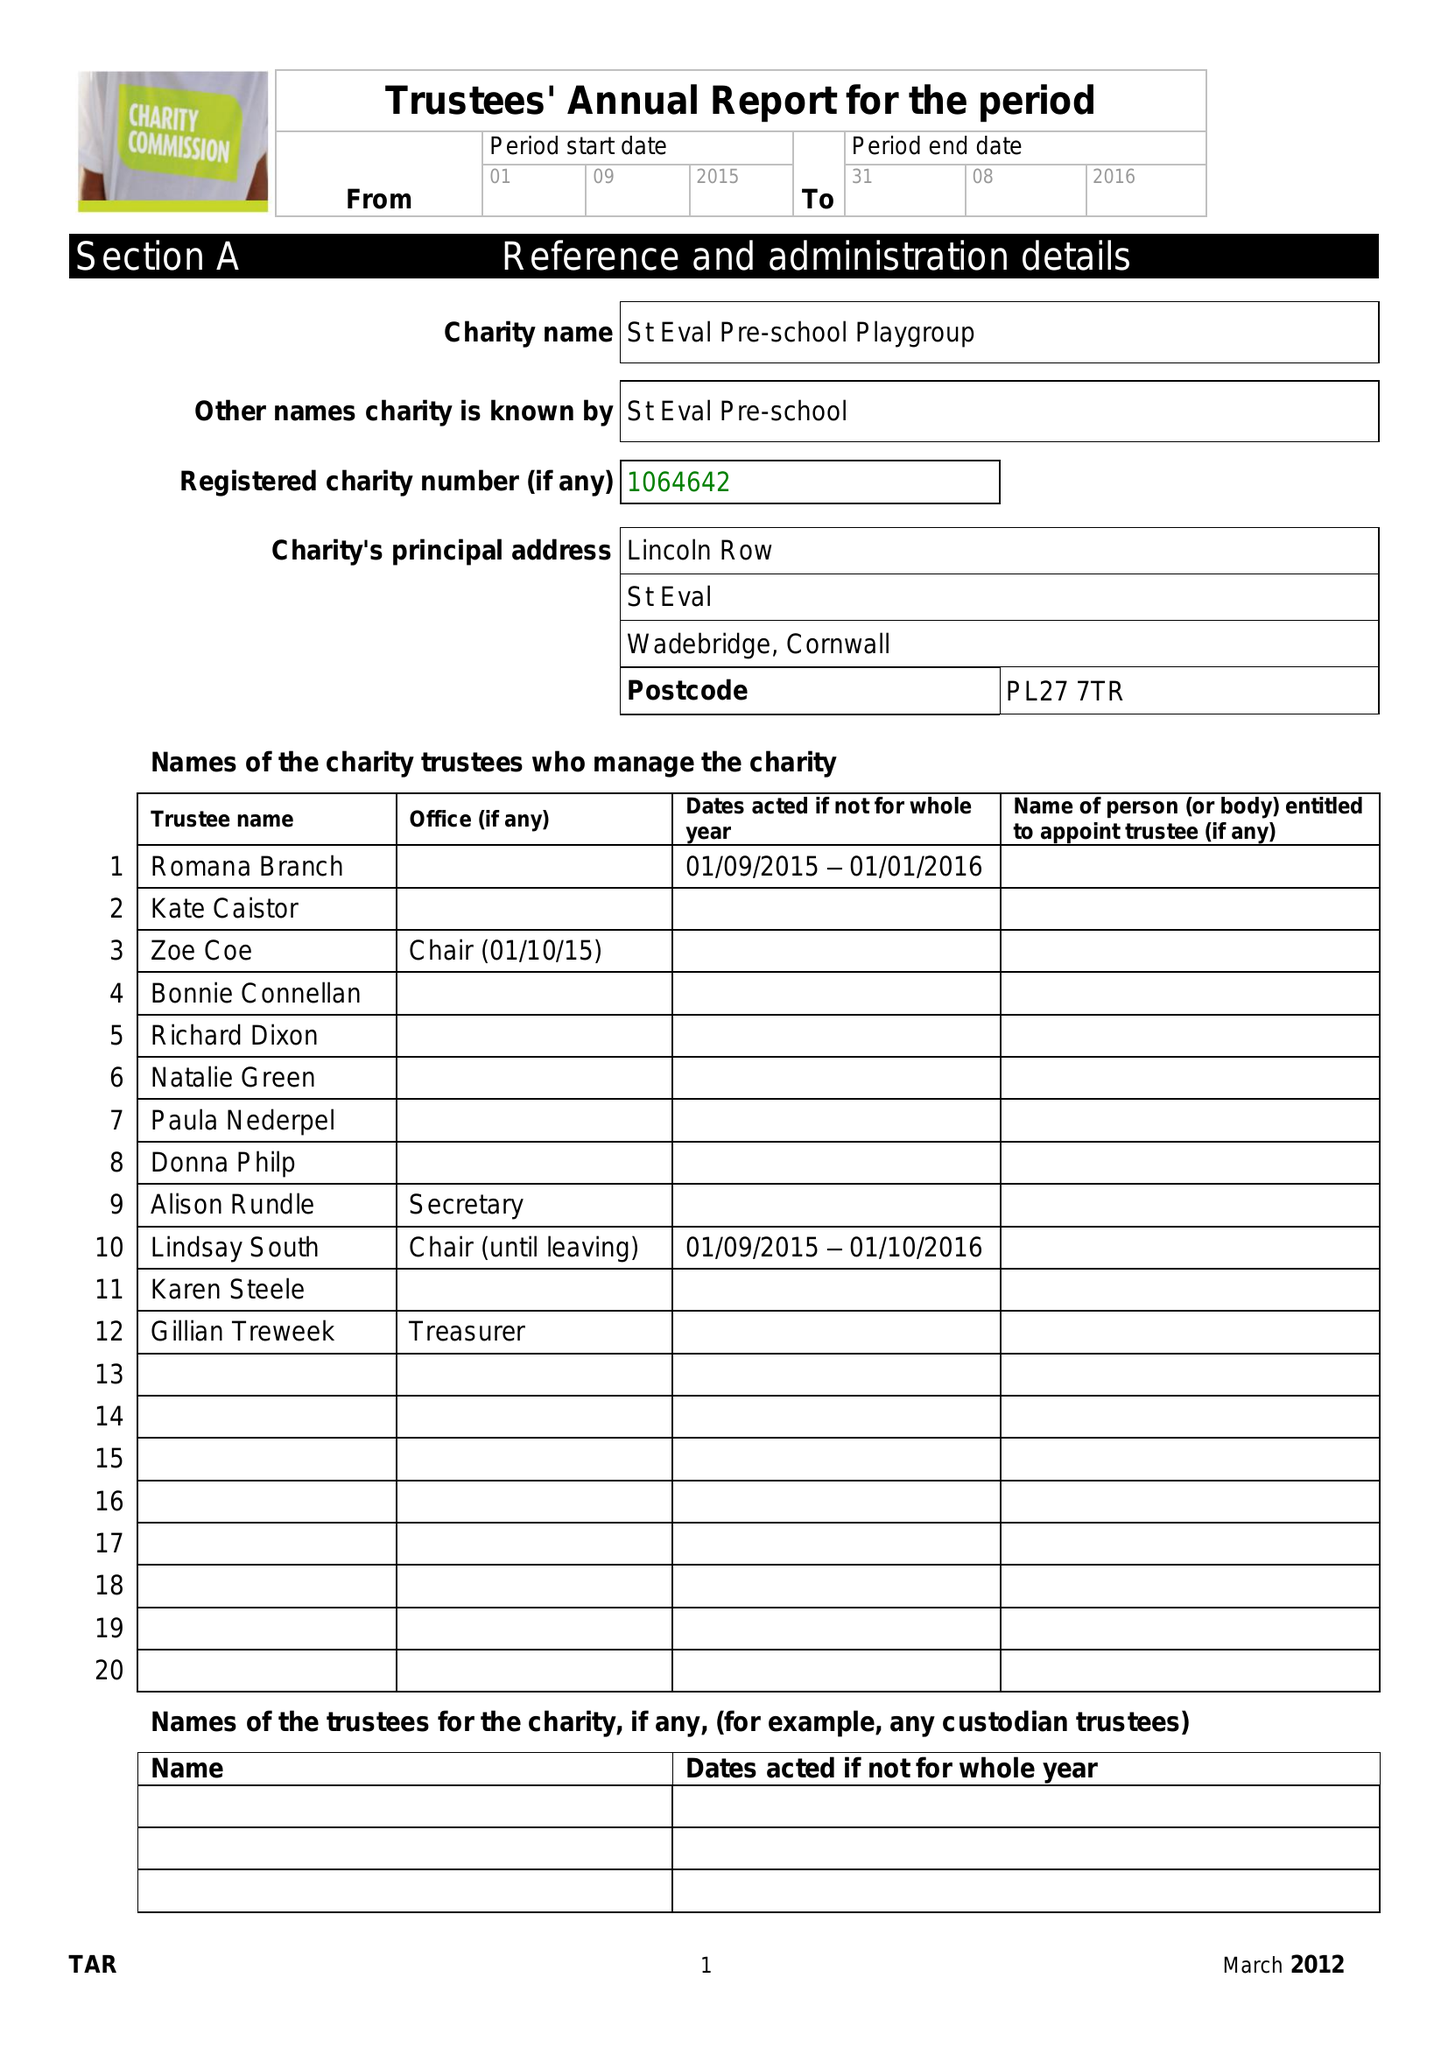What is the value for the address__post_town?
Answer the question using a single word or phrase. WADEBRIDGE 